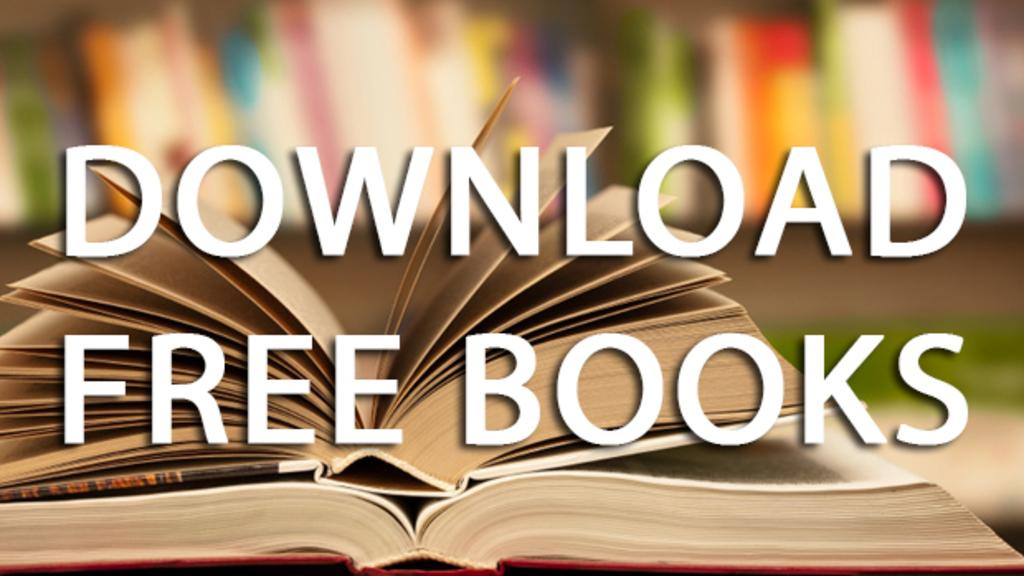<image>
Create a compact narrative representing the image presented. an ad to download more books with an open book 